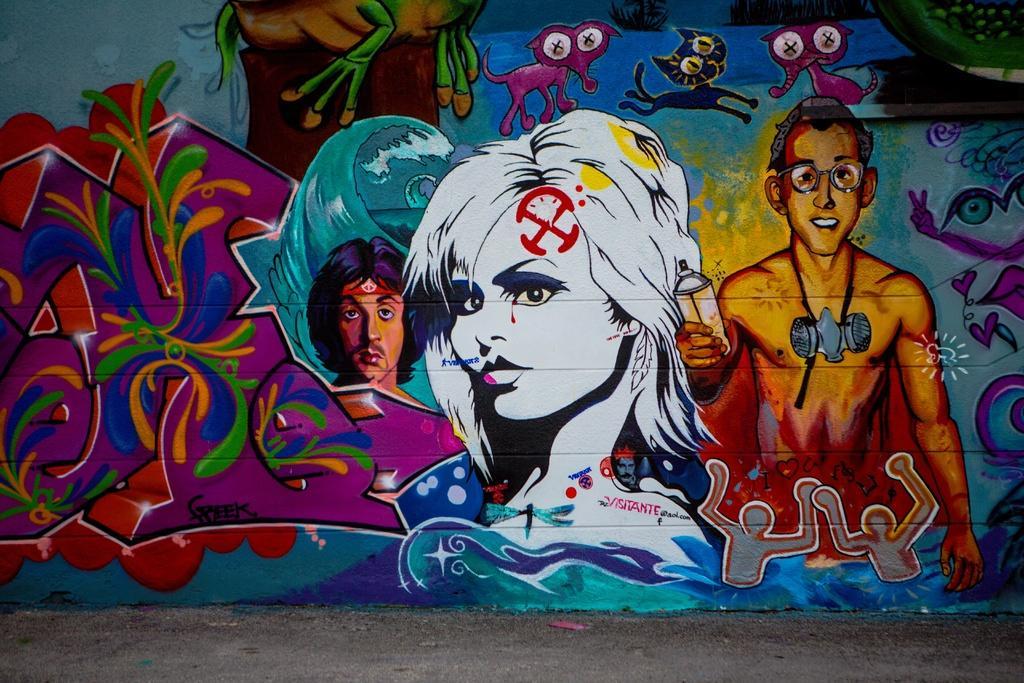Describe this image in one or two sentences. In this picture we can see the ground and a painting of some people, animals on the wall. 